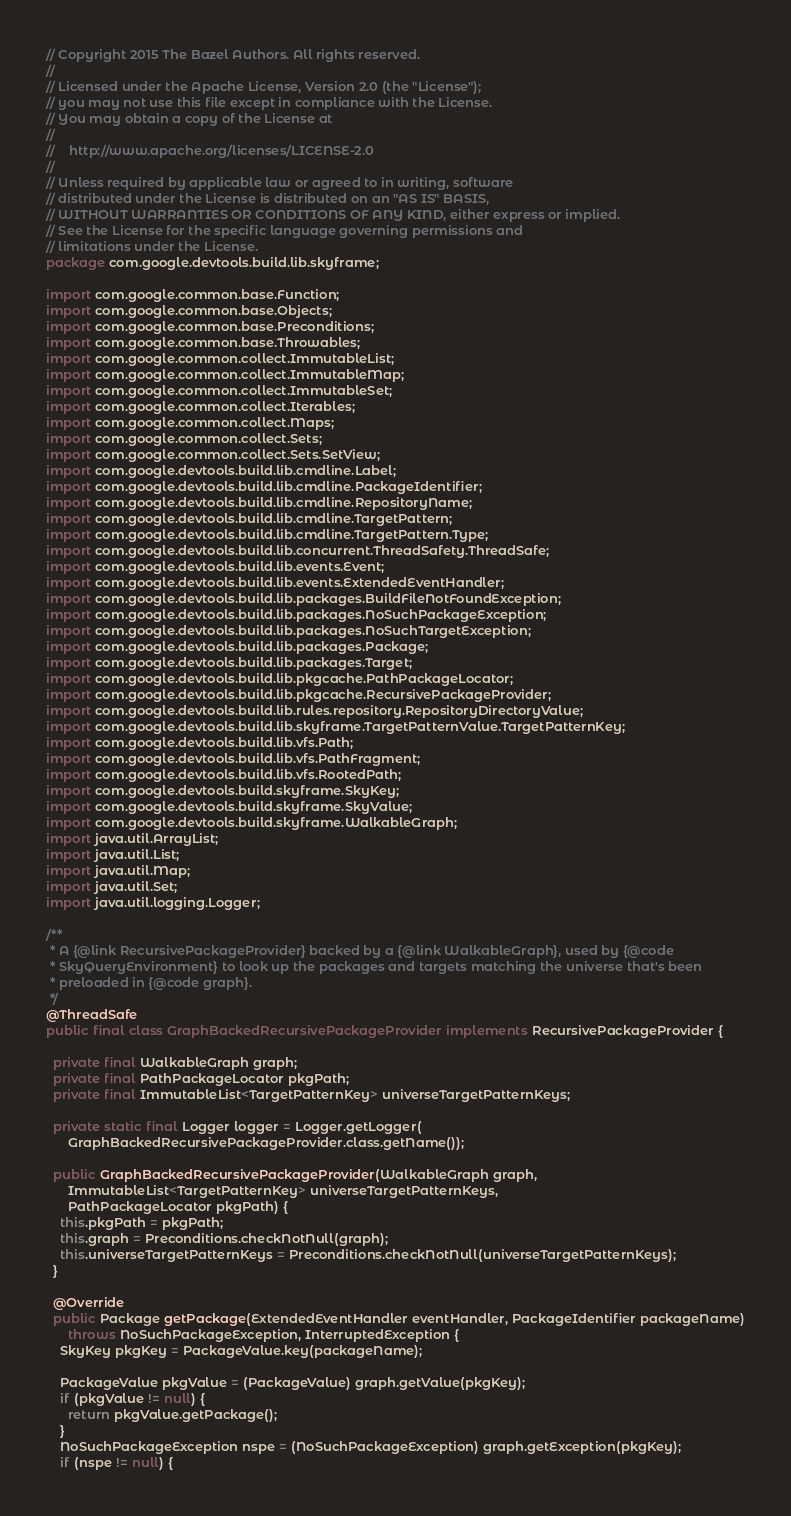Convert code to text. <code><loc_0><loc_0><loc_500><loc_500><_Java_>// Copyright 2015 The Bazel Authors. All rights reserved.
//
// Licensed under the Apache License, Version 2.0 (the "License");
// you may not use this file except in compliance with the License.
// You may obtain a copy of the License at
//
//    http://www.apache.org/licenses/LICENSE-2.0
//
// Unless required by applicable law or agreed to in writing, software
// distributed under the License is distributed on an "AS IS" BASIS,
// WITHOUT WARRANTIES OR CONDITIONS OF ANY KIND, either express or implied.
// See the License for the specific language governing permissions and
// limitations under the License.
package com.google.devtools.build.lib.skyframe;

import com.google.common.base.Function;
import com.google.common.base.Objects;
import com.google.common.base.Preconditions;
import com.google.common.base.Throwables;
import com.google.common.collect.ImmutableList;
import com.google.common.collect.ImmutableMap;
import com.google.common.collect.ImmutableSet;
import com.google.common.collect.Iterables;
import com.google.common.collect.Maps;
import com.google.common.collect.Sets;
import com.google.common.collect.Sets.SetView;
import com.google.devtools.build.lib.cmdline.Label;
import com.google.devtools.build.lib.cmdline.PackageIdentifier;
import com.google.devtools.build.lib.cmdline.RepositoryName;
import com.google.devtools.build.lib.cmdline.TargetPattern;
import com.google.devtools.build.lib.cmdline.TargetPattern.Type;
import com.google.devtools.build.lib.concurrent.ThreadSafety.ThreadSafe;
import com.google.devtools.build.lib.events.Event;
import com.google.devtools.build.lib.events.ExtendedEventHandler;
import com.google.devtools.build.lib.packages.BuildFileNotFoundException;
import com.google.devtools.build.lib.packages.NoSuchPackageException;
import com.google.devtools.build.lib.packages.NoSuchTargetException;
import com.google.devtools.build.lib.packages.Package;
import com.google.devtools.build.lib.packages.Target;
import com.google.devtools.build.lib.pkgcache.PathPackageLocator;
import com.google.devtools.build.lib.pkgcache.RecursivePackageProvider;
import com.google.devtools.build.lib.rules.repository.RepositoryDirectoryValue;
import com.google.devtools.build.lib.skyframe.TargetPatternValue.TargetPatternKey;
import com.google.devtools.build.lib.vfs.Path;
import com.google.devtools.build.lib.vfs.PathFragment;
import com.google.devtools.build.lib.vfs.RootedPath;
import com.google.devtools.build.skyframe.SkyKey;
import com.google.devtools.build.skyframe.SkyValue;
import com.google.devtools.build.skyframe.WalkableGraph;
import java.util.ArrayList;
import java.util.List;
import java.util.Map;
import java.util.Set;
import java.util.logging.Logger;

/**
 * A {@link RecursivePackageProvider} backed by a {@link WalkableGraph}, used by {@code
 * SkyQueryEnvironment} to look up the packages and targets matching the universe that's been
 * preloaded in {@code graph}.
 */
@ThreadSafe
public final class GraphBackedRecursivePackageProvider implements RecursivePackageProvider {

  private final WalkableGraph graph;
  private final PathPackageLocator pkgPath;
  private final ImmutableList<TargetPatternKey> universeTargetPatternKeys;

  private static final Logger logger = Logger.getLogger(
      GraphBackedRecursivePackageProvider.class.getName());

  public GraphBackedRecursivePackageProvider(WalkableGraph graph,
      ImmutableList<TargetPatternKey> universeTargetPatternKeys,
      PathPackageLocator pkgPath) {
    this.pkgPath = pkgPath;
    this.graph = Preconditions.checkNotNull(graph);
    this.universeTargetPatternKeys = Preconditions.checkNotNull(universeTargetPatternKeys);
  }

  @Override
  public Package getPackage(ExtendedEventHandler eventHandler, PackageIdentifier packageName)
      throws NoSuchPackageException, InterruptedException {
    SkyKey pkgKey = PackageValue.key(packageName);

    PackageValue pkgValue = (PackageValue) graph.getValue(pkgKey);
    if (pkgValue != null) {
      return pkgValue.getPackage();
    }
    NoSuchPackageException nspe = (NoSuchPackageException) graph.getException(pkgKey);
    if (nspe != null) {</code> 